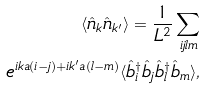<formula> <loc_0><loc_0><loc_500><loc_500>\langle \hat { n } _ { k } \hat { n } _ { k ^ { \prime } } \rangle = \frac { 1 } { L ^ { 2 } } \sum _ { i j l m } \\ e ^ { i k a ( i - j ) + i k ^ { \prime } a ( l - m ) } \langle \hat { b } ^ { \dag } _ { i } \hat { b } _ { j } \hat { b } ^ { \dag } _ { l } \hat { b } _ { m } \rangle ,</formula> 